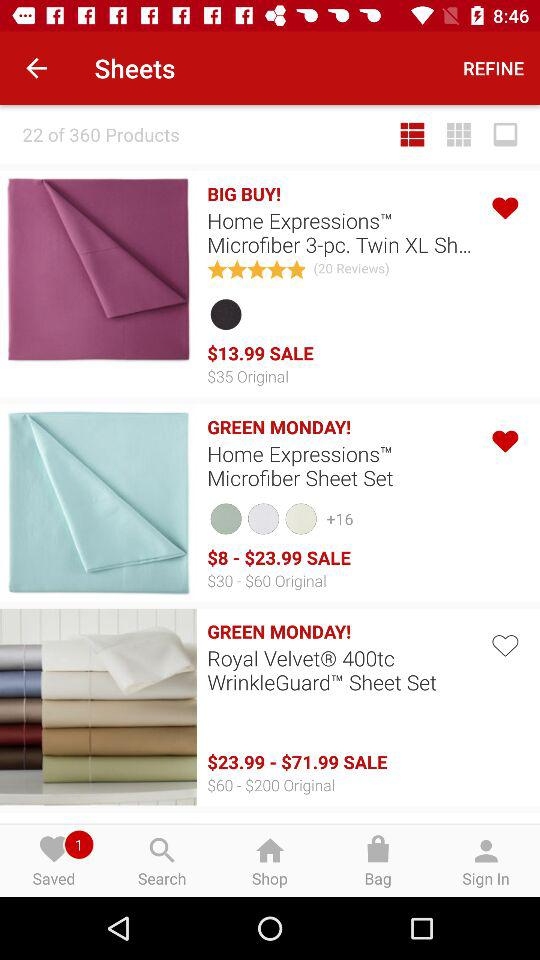How many green monday items are there?
Answer the question using a single word or phrase. 2 